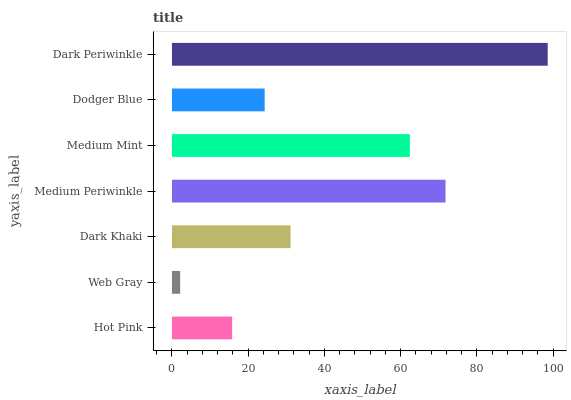Is Web Gray the minimum?
Answer yes or no. Yes. Is Dark Periwinkle the maximum?
Answer yes or no. Yes. Is Dark Khaki the minimum?
Answer yes or no. No. Is Dark Khaki the maximum?
Answer yes or no. No. Is Dark Khaki greater than Web Gray?
Answer yes or no. Yes. Is Web Gray less than Dark Khaki?
Answer yes or no. Yes. Is Web Gray greater than Dark Khaki?
Answer yes or no. No. Is Dark Khaki less than Web Gray?
Answer yes or no. No. Is Dark Khaki the high median?
Answer yes or no. Yes. Is Dark Khaki the low median?
Answer yes or no. Yes. Is Medium Mint the high median?
Answer yes or no. No. Is Web Gray the low median?
Answer yes or no. No. 